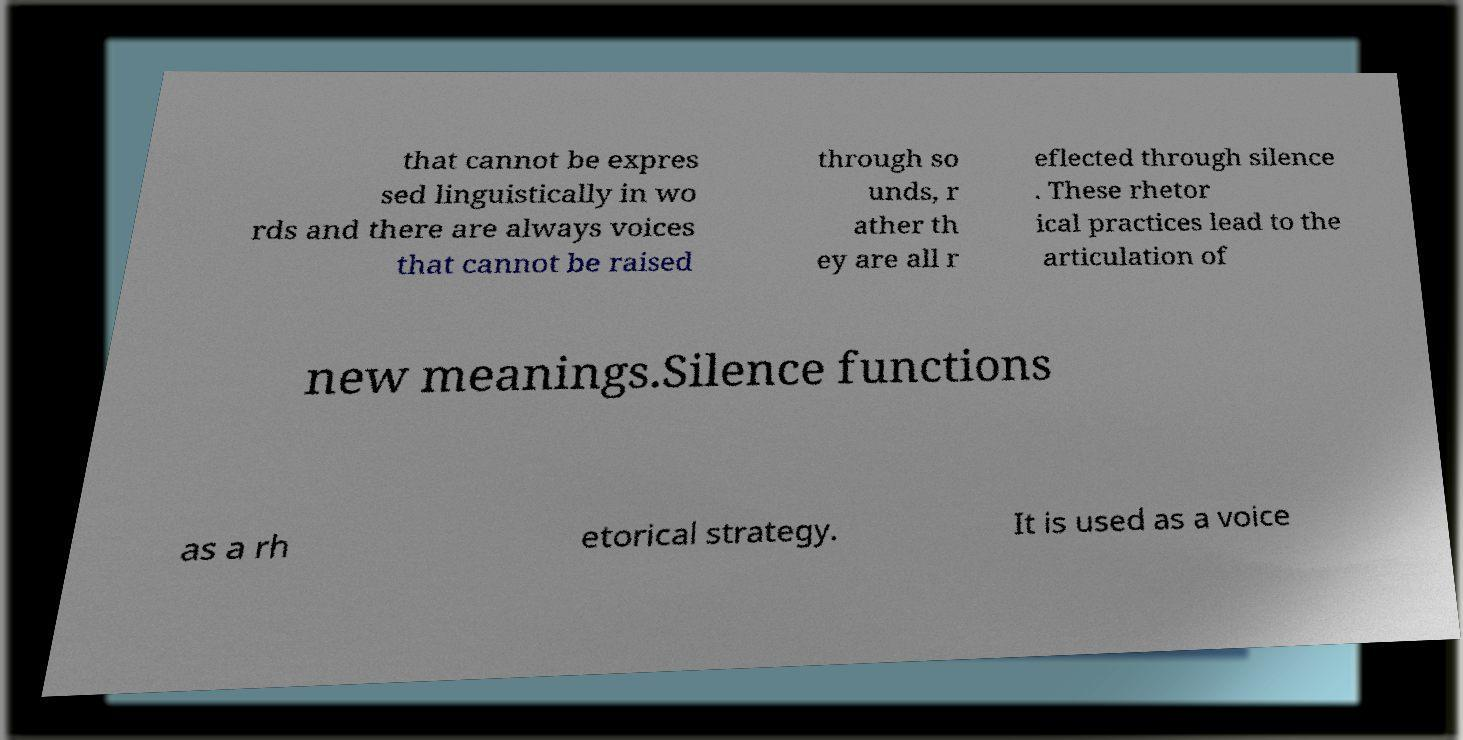Please read and relay the text visible in this image. What does it say? that cannot be expres sed linguistically in wo rds and there are always voices that cannot be raised through so unds, r ather th ey are all r eflected through silence . These rhetor ical practices lead to the articulation of new meanings.Silence functions as a rh etorical strategy. It is used as a voice 